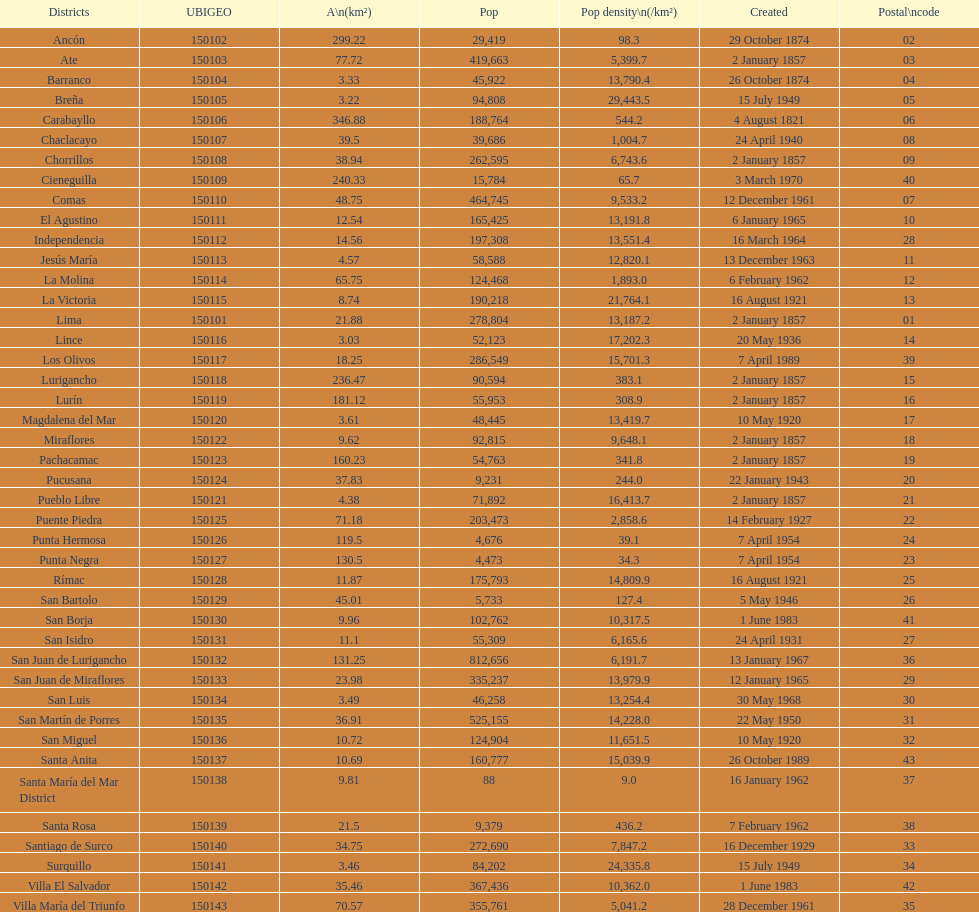Which district in this city has the greatest population? San Juan de Lurigancho. 